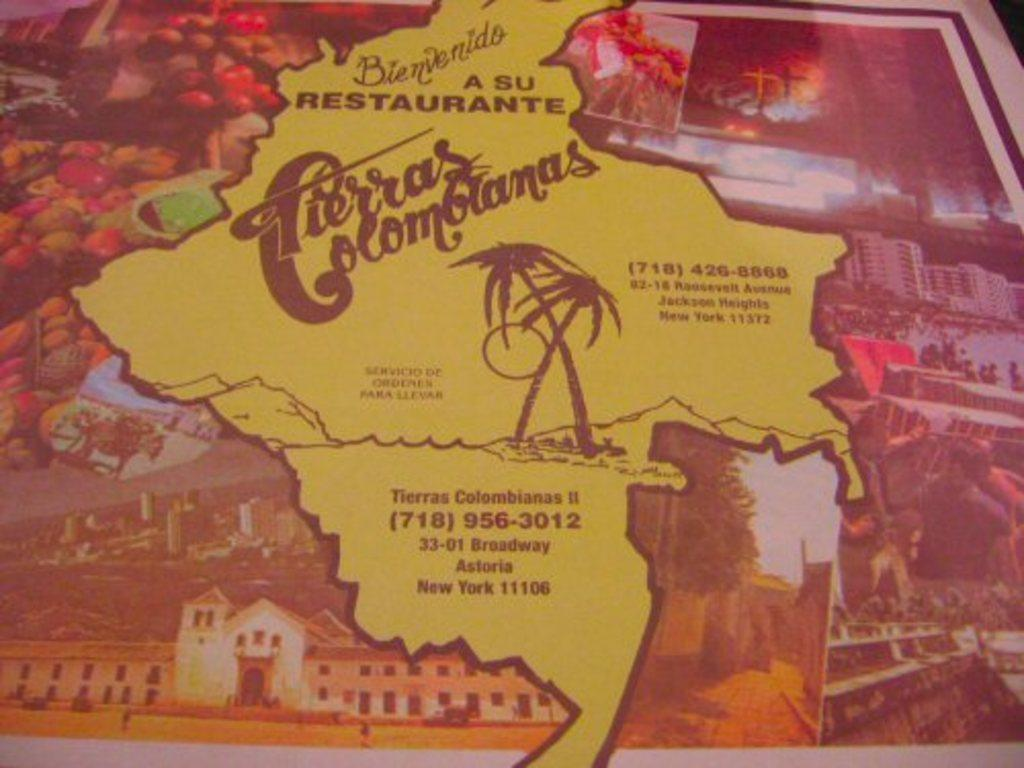What object is present in the image that typically holds photos or images? A: There is a photo frame in the image. What type of content is present within the photo frame? The photo frame contains text, images of buildings, and images of fruits. What type of plastic material is used to make the tub in the image? There is no tub present in the image. What type of competition is being held in the image? There is no competition present in the image. 